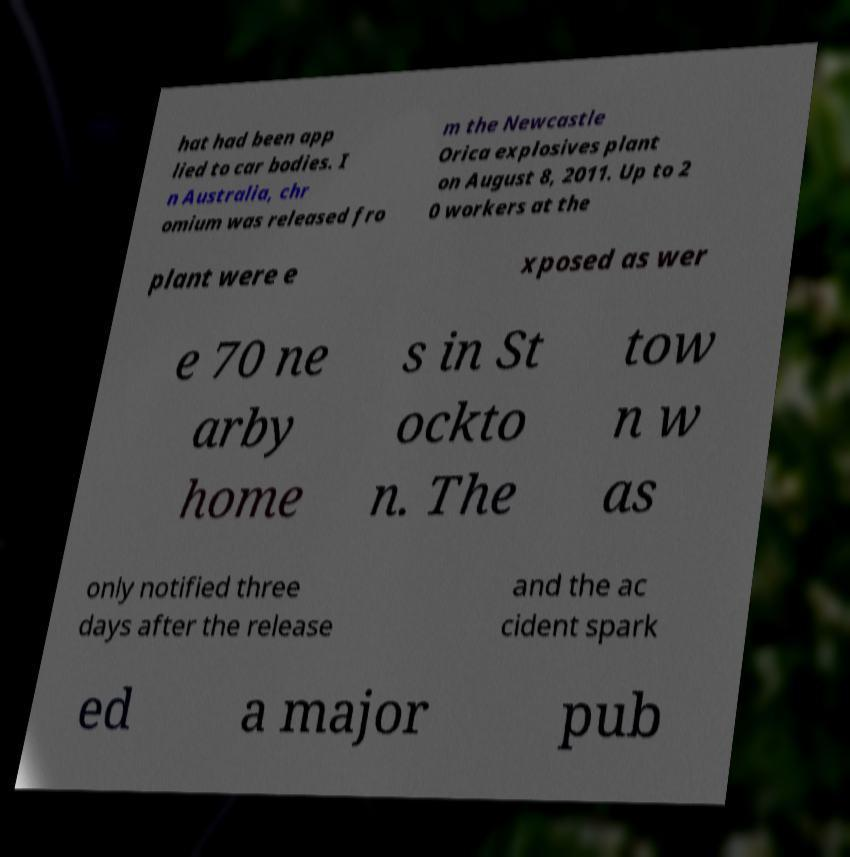For documentation purposes, I need the text within this image transcribed. Could you provide that? hat had been app lied to car bodies. I n Australia, chr omium was released fro m the Newcastle Orica explosives plant on August 8, 2011. Up to 2 0 workers at the plant were e xposed as wer e 70 ne arby home s in St ockto n. The tow n w as only notified three days after the release and the ac cident spark ed a major pub 